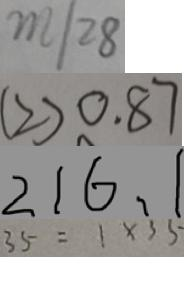Convert formula to latex. <formula><loc_0><loc_0><loc_500><loc_500>m / 2 8 
 ( 2 ) 0 . 8 7 
 2 1 6 , 1 
 3 5 = 1 \times 3 5</formula> 